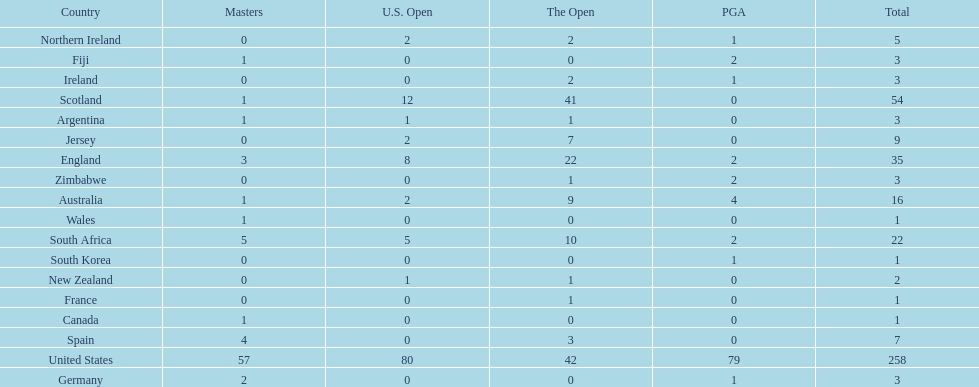How many countries have produced the same number of championship golfers as canada? 3. 